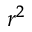<formula> <loc_0><loc_0><loc_500><loc_500>r ^ { 2 }</formula> 